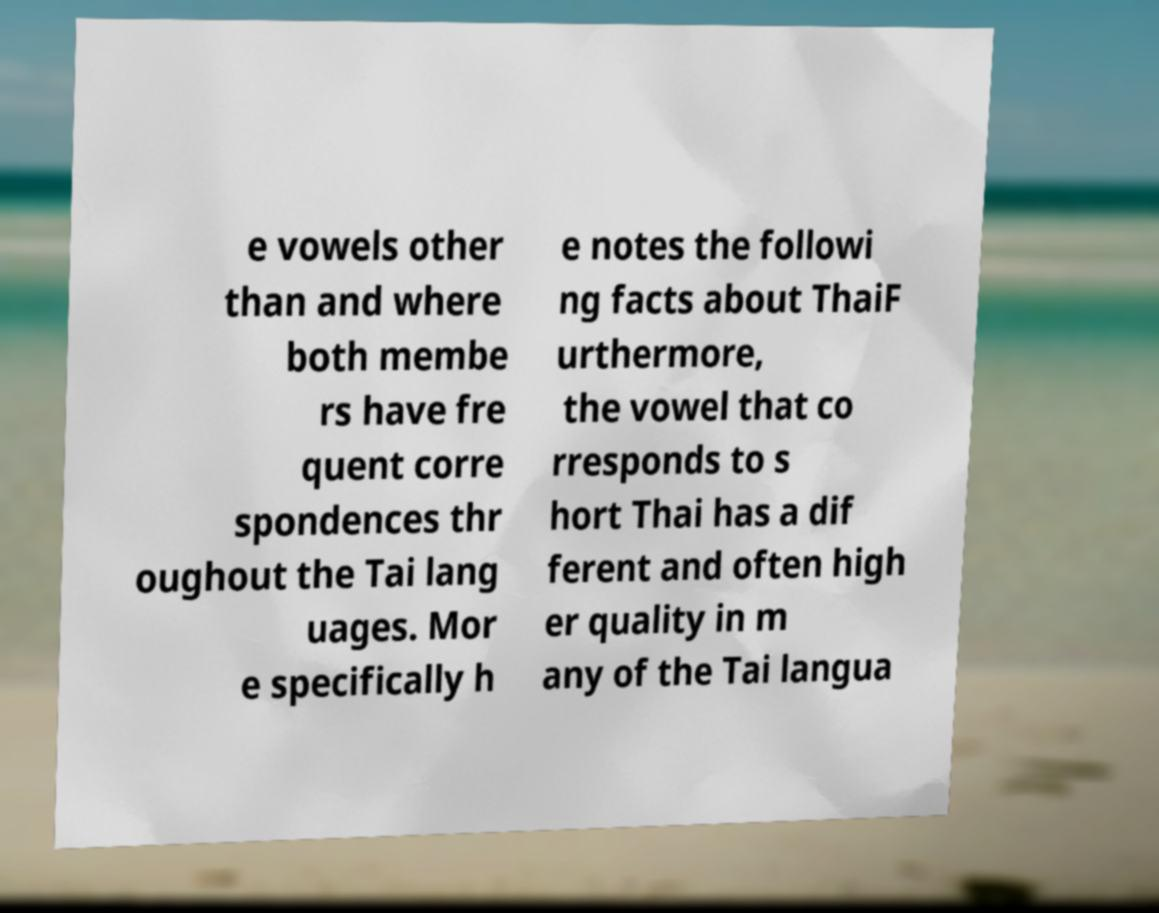What messages or text are displayed in this image? I need them in a readable, typed format. e vowels other than and where both membe rs have fre quent corre spondences thr oughout the Tai lang uages. Mor e specifically h e notes the followi ng facts about ThaiF urthermore, the vowel that co rresponds to s hort Thai has a dif ferent and often high er quality in m any of the Tai langua 